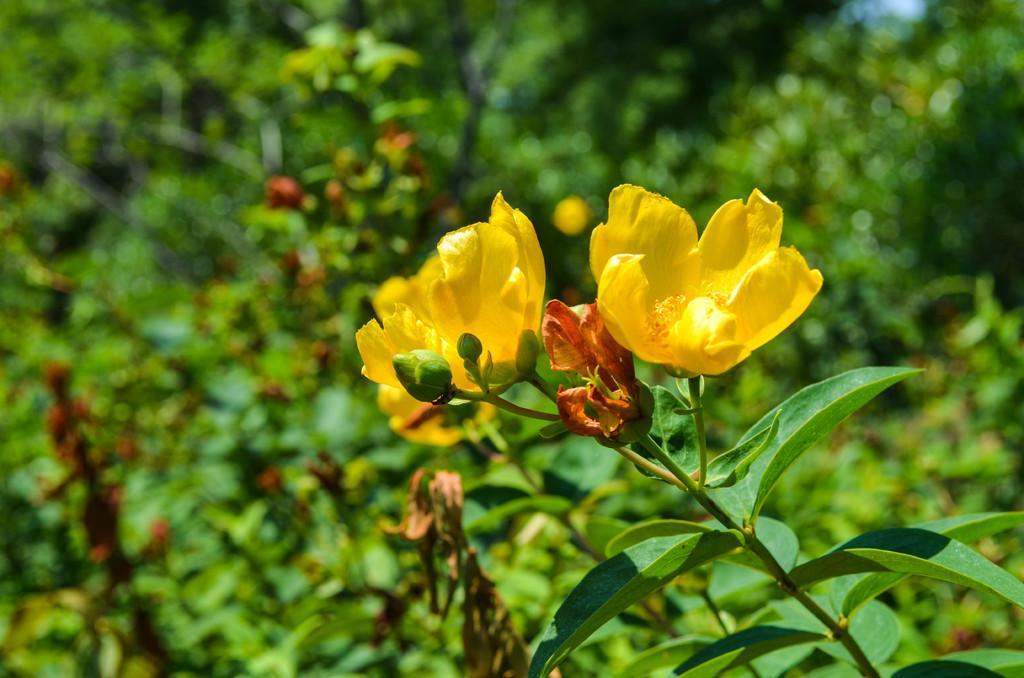What is visible in the foreground of the image? There are flowers, buds, stems, and leaves in the foreground of the image. Can you describe the flowers in the image? The flowers have buds and stems, and they are surrounded by leaves. What can be seen in the background of the image? There is greenery in the background of the image. What color is the ice in the image? There is no ice present in the image; it features flowers, buds, stems, and leaves. How many people are in the crowd in the image? There is no crowd present in the image; it features flowers, buds, stems, and leaves. 